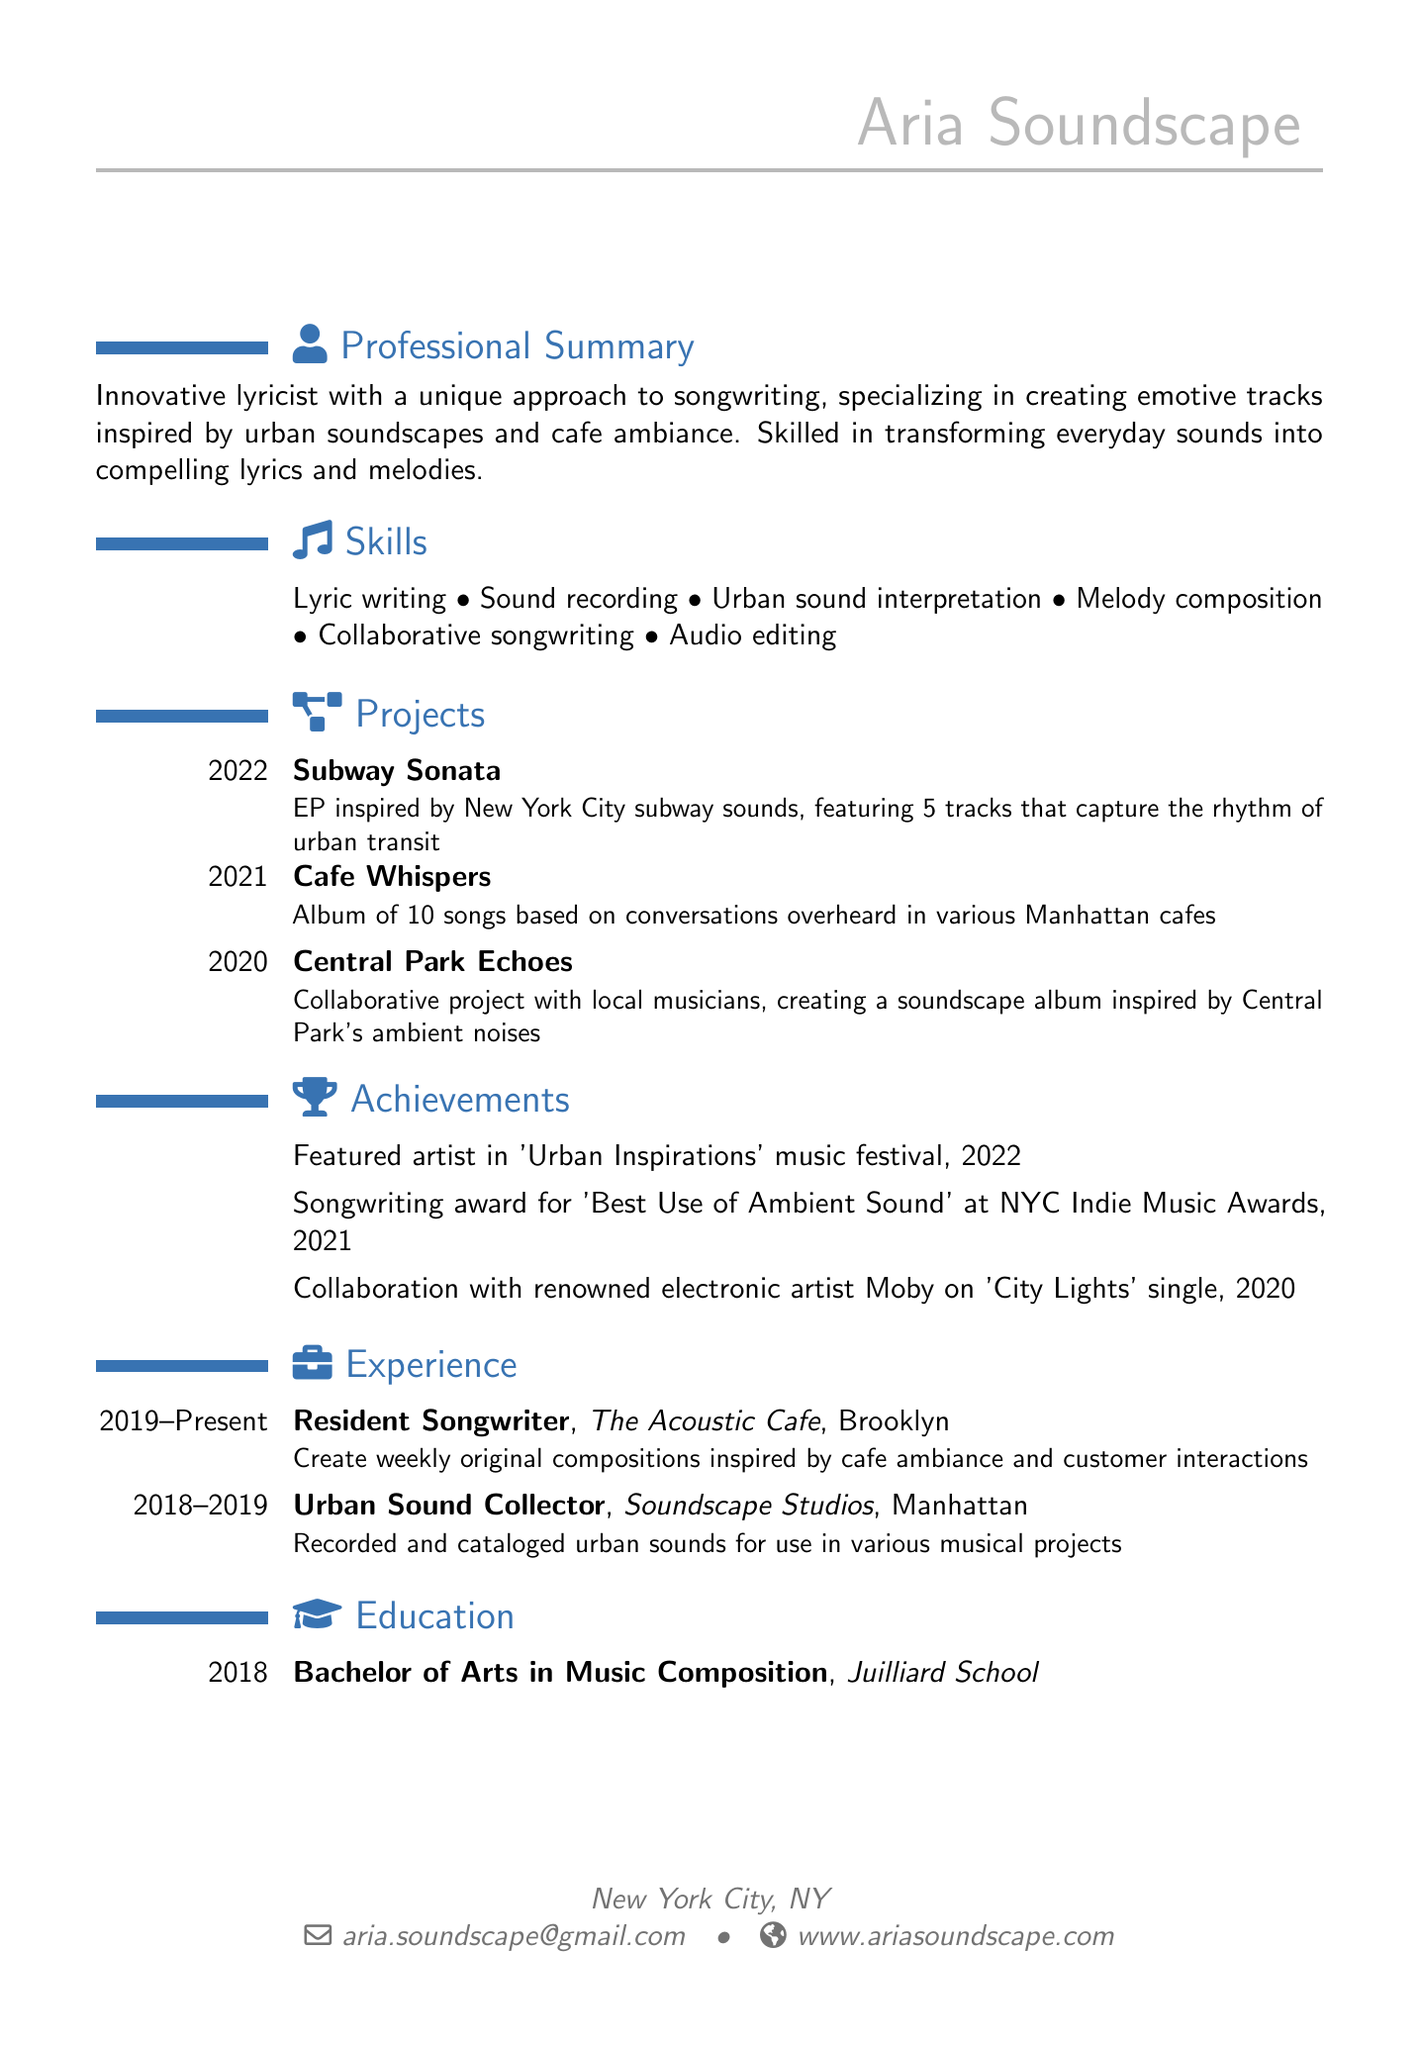What is the name of the lyricist? The document states the name of the lyricist as "Aria Soundscape."
Answer: Aria Soundscape What is the location listed on the resume? The resume indicates that the lyricist is located in "New York City, NY."
Answer: New York City, NY Which project was released in 2021? The document lists "Cafe Whispers" as the project released in 2021.
Answer: Cafe Whispers How many skills are mentioned in the resume? The skills section lists six different skills, which totals to six.
Answer: 6 What award did Aria win in 2021? According to the document, Aria was awarded for "Best Use of Ambient Sound."
Answer: Best Use of Ambient Sound Which institution did Aria graduate from? The resume indicates that Aria graduated from the "Juilliard School."
Answer: Juilliard School What is the title of the EP inspired by subway sounds? The document specifies the EP's title as "Subway Sonata."
Answer: Subway Sonata How long has Aria been a resident songwriter? The resume states the duration as "2019 - Present," indicating several years' experience.
Answer: 2019 - Present What is the collaborative project mentioned in the document? The document refers to "Central Park Echoes" as a collaborative project.
Answer: Central Park Echoes 